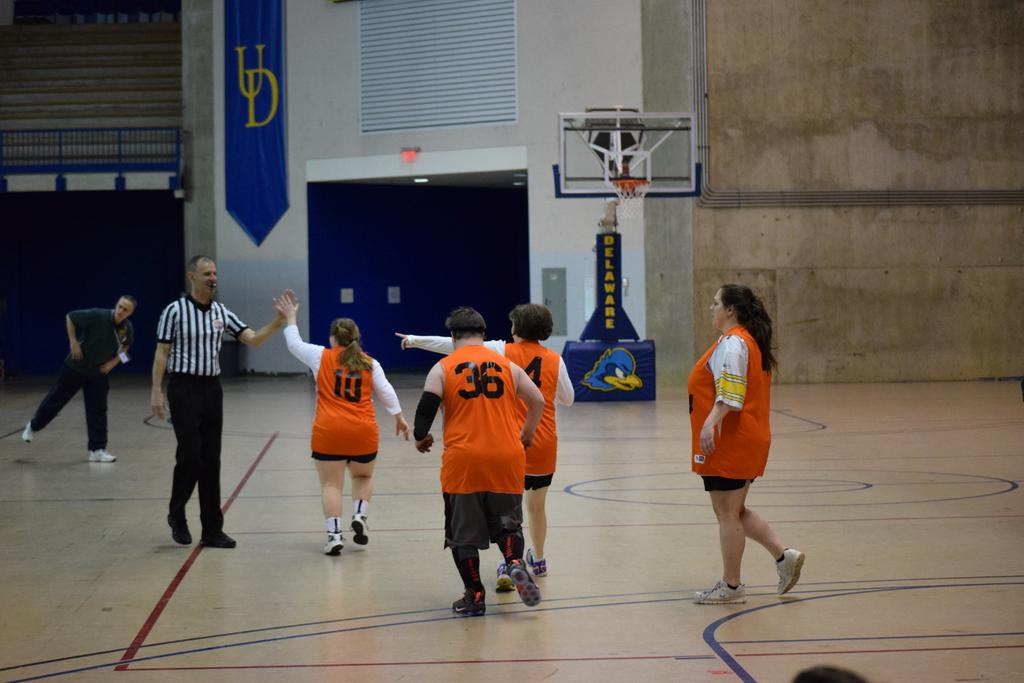What are the people in the image doing? The people in the image are on the ground. What can be seen in the background of the image? There is a wall and a basketball hoop in the background of the image. Are there any other objects visible in the background? Yes, there are objects visible in the background of the image. What color is the crayon being used by the people in the image? There is no crayon present in the image; the people are on the ground, and there are objects visible in the background, but no crayons are mentioned. 